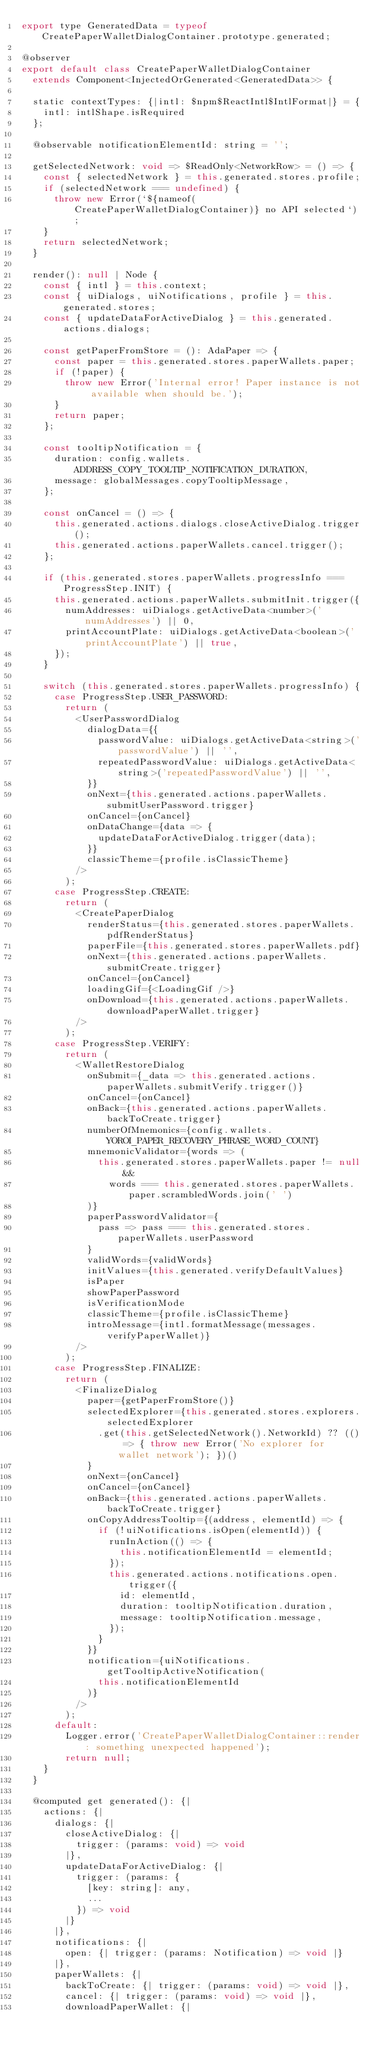Convert code to text. <code><loc_0><loc_0><loc_500><loc_500><_JavaScript_>export type GeneratedData = typeof CreatePaperWalletDialogContainer.prototype.generated;

@observer
export default class CreatePaperWalletDialogContainer
  extends Component<InjectedOrGenerated<GeneratedData>> {

  static contextTypes: {|intl: $npm$ReactIntl$IntlFormat|} = {
    intl: intlShape.isRequired
  };

  @observable notificationElementId: string = '';

  getSelectedNetwork: void => $ReadOnly<NetworkRow> = () => {
    const { selectedNetwork } = this.generated.stores.profile;
    if (selectedNetwork === undefined) {
      throw new Error(`${nameof(CreatePaperWalletDialogContainer)} no API selected`);
    }
    return selectedNetwork;
  }

  render(): null | Node {
    const { intl } = this.context;
    const { uiDialogs, uiNotifications, profile } = this.generated.stores;
    const { updateDataForActiveDialog } = this.generated.actions.dialogs;

    const getPaperFromStore = (): AdaPaper => {
      const paper = this.generated.stores.paperWallets.paper;
      if (!paper) {
        throw new Error('Internal error! Paper instance is not available when should be.');
      }
      return paper;
    };

    const tooltipNotification = {
      duration: config.wallets.ADDRESS_COPY_TOOLTIP_NOTIFICATION_DURATION,
      message: globalMessages.copyTooltipMessage,
    };

    const onCancel = () => {
      this.generated.actions.dialogs.closeActiveDialog.trigger();
      this.generated.actions.paperWallets.cancel.trigger();
    };

    if (this.generated.stores.paperWallets.progressInfo === ProgressStep.INIT) {
      this.generated.actions.paperWallets.submitInit.trigger({
        numAddresses: uiDialogs.getActiveData<number>('numAddresses') || 0,
        printAccountPlate: uiDialogs.getActiveData<boolean>('printAccountPlate') || true,
      });
    }

    switch (this.generated.stores.paperWallets.progressInfo) {
      case ProgressStep.USER_PASSWORD:
        return (
          <UserPasswordDialog
            dialogData={{
              passwordValue: uiDialogs.getActiveData<string>('passwordValue') || '',
              repeatedPasswordValue: uiDialogs.getActiveData<string>('repeatedPasswordValue') || '',
            }}
            onNext={this.generated.actions.paperWallets.submitUserPassword.trigger}
            onCancel={onCancel}
            onDataChange={data => {
              updateDataForActiveDialog.trigger(data);
            }}
            classicTheme={profile.isClassicTheme}
          />
        );
      case ProgressStep.CREATE:
        return (
          <CreatePaperDialog
            renderStatus={this.generated.stores.paperWallets.pdfRenderStatus}
            paperFile={this.generated.stores.paperWallets.pdf}
            onNext={this.generated.actions.paperWallets.submitCreate.trigger}
            onCancel={onCancel}
            loadingGif={<LoadingGif />}
            onDownload={this.generated.actions.paperWallets.downloadPaperWallet.trigger}
          />
        );
      case ProgressStep.VERIFY:
        return (
          <WalletRestoreDialog
            onSubmit={_data => this.generated.actions.paperWallets.submitVerify.trigger()}
            onCancel={onCancel}
            onBack={this.generated.actions.paperWallets.backToCreate.trigger}
            numberOfMnemonics={config.wallets.YOROI_PAPER_RECOVERY_PHRASE_WORD_COUNT}
            mnemonicValidator={words => (
              this.generated.stores.paperWallets.paper != null &&
                words === this.generated.stores.paperWallets.paper.scrambledWords.join(' ')
            )}
            paperPasswordValidator={
              pass => pass === this.generated.stores.paperWallets.userPassword
            }
            validWords={validWords}
            initValues={this.generated.verifyDefaultValues}
            isPaper
            showPaperPassword
            isVerificationMode
            classicTheme={profile.isClassicTheme}
            introMessage={intl.formatMessage(messages.verifyPaperWallet)}
          />
        );
      case ProgressStep.FINALIZE:
        return (
          <FinalizeDialog
            paper={getPaperFromStore()}
            selectedExplorer={this.generated.stores.explorers.selectedExplorer
              .get(this.getSelectedNetwork().NetworkId) ?? (() => { throw new Error('No explorer for wallet network'); })()
            }
            onNext={onCancel}
            onCancel={onCancel}
            onBack={this.generated.actions.paperWallets.backToCreate.trigger}
            onCopyAddressTooltip={(address, elementId) => {
              if (!uiNotifications.isOpen(elementId)) {
                runInAction(() => {
                  this.notificationElementId = elementId;
                });
                this.generated.actions.notifications.open.trigger({
                  id: elementId,
                  duration: tooltipNotification.duration,
                  message: tooltipNotification.message,
                });
              }
            }}
            notification={uiNotifications.getTooltipActiveNotification(
              this.notificationElementId
            )}
          />
        );
      default:
        Logger.error('CreatePaperWalletDialogContainer::render: something unexpected happened');
        return null;
    }
  }

  @computed get generated(): {|
    actions: {|
      dialogs: {|
        closeActiveDialog: {|
          trigger: (params: void) => void
        |},
        updateDataForActiveDialog: {|
          trigger: (params: {
            [key: string]: any,
            ...
          }) => void
        |}
      |},
      notifications: {|
        open: {| trigger: (params: Notification) => void |}
      |},
      paperWallets: {|
        backToCreate: {| trigger: (params: void) => void |},
        cancel: {| trigger: (params: void) => void |},
        downloadPaperWallet: {|</code> 